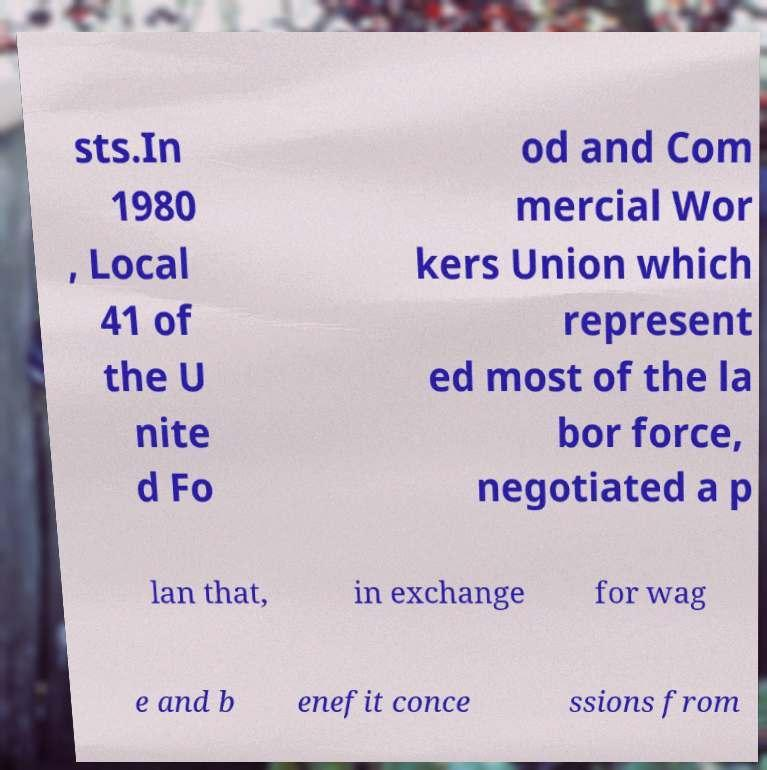For documentation purposes, I need the text within this image transcribed. Could you provide that? sts.In 1980 , Local 41 of the U nite d Fo od and Com mercial Wor kers Union which represent ed most of the la bor force, negotiated a p lan that, in exchange for wag e and b enefit conce ssions from 